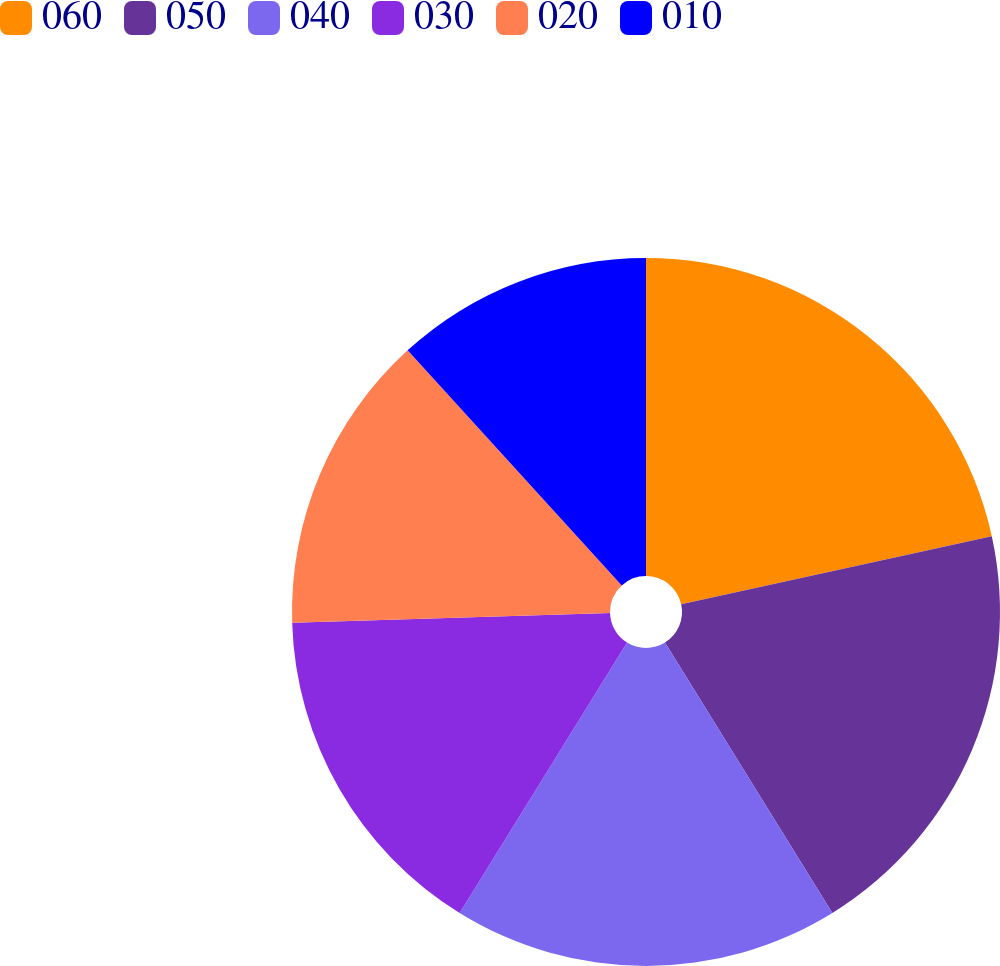Convert chart. <chart><loc_0><loc_0><loc_500><loc_500><pie_chart><fcel>060<fcel>050<fcel>040<fcel>030<fcel>020<fcel>010<nl><fcel>21.57%<fcel>19.61%<fcel>17.65%<fcel>15.69%<fcel>13.73%<fcel>11.76%<nl></chart> 